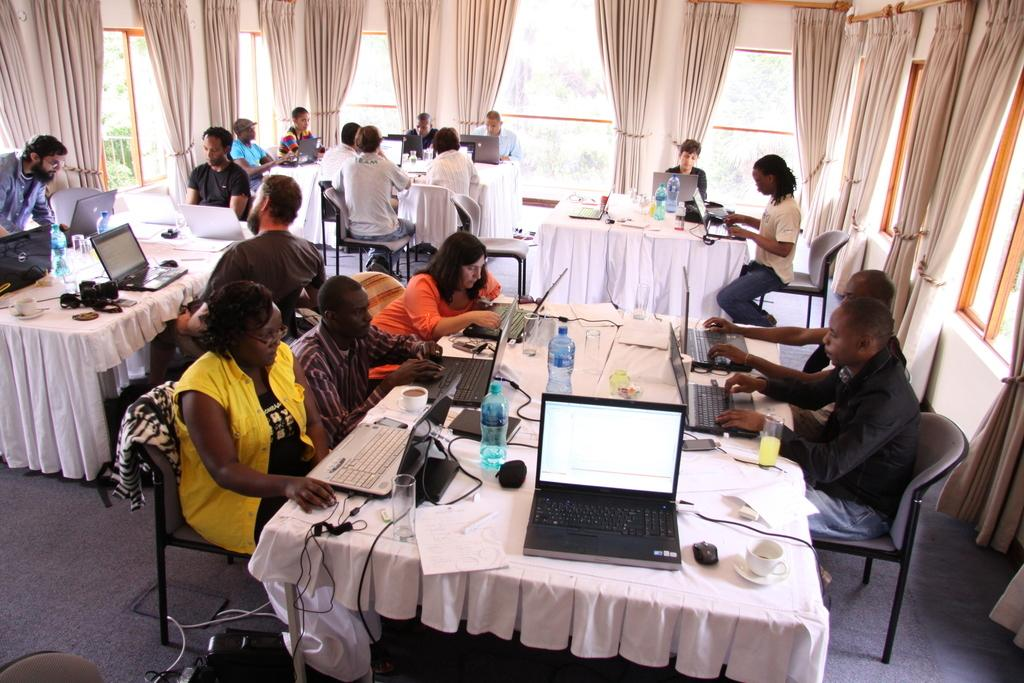What are the people in the image doing? People are seated on chairs in the image. What objects are around the chairs? Tables are present around the chairs. What electronic device can be seen on the table? There is a laptop on the table. What else is visible on the table? Power cables, a cup, a saucer, and a glass are on the table. What can be seen in the background of the image? There are windows behind the people. What type of window treatment is present? Curtains are associated with the windows. What type of brain activity can be observed in the image? There is no indication of brain activity in the image; it shows people seated at tables with various objects. What question is being asked by the person in the image? There is no person asking a question in the image; it only shows people seated at tables with various objects. 